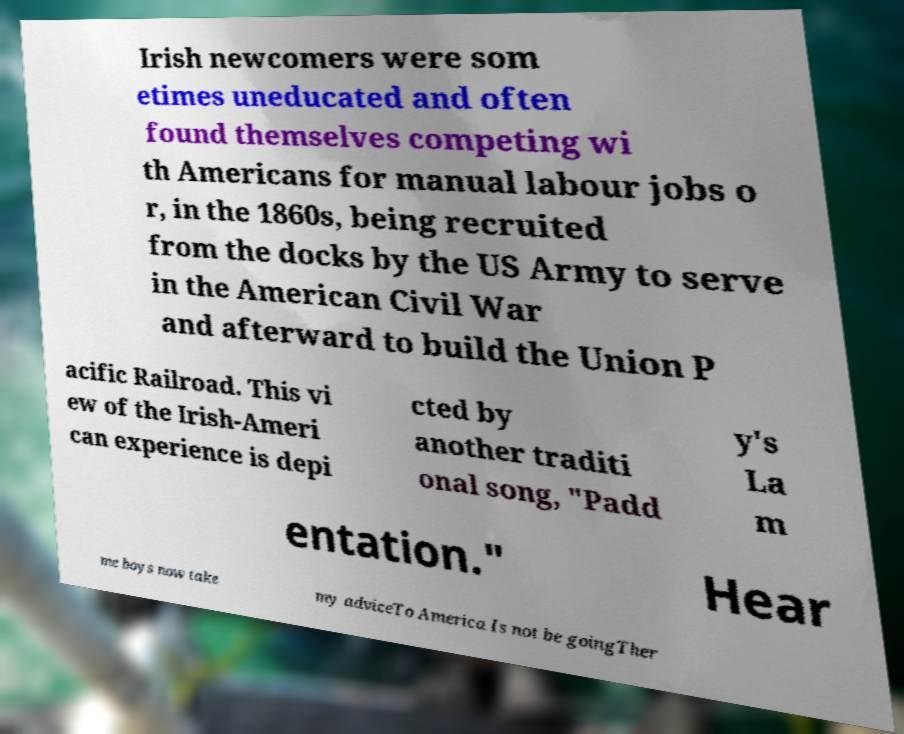There's text embedded in this image that I need extracted. Can you transcribe it verbatim? Irish newcomers were som etimes uneducated and often found themselves competing wi th Americans for manual labour jobs o r, in the 1860s, being recruited from the docks by the US Army to serve in the American Civil War and afterward to build the Union P acific Railroad. This vi ew of the Irish-Ameri can experience is depi cted by another traditi onal song, "Padd y's La m entation." Hear me boys now take my adviceTo America Is not be goingTher 